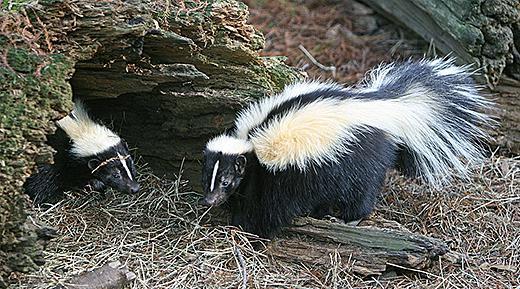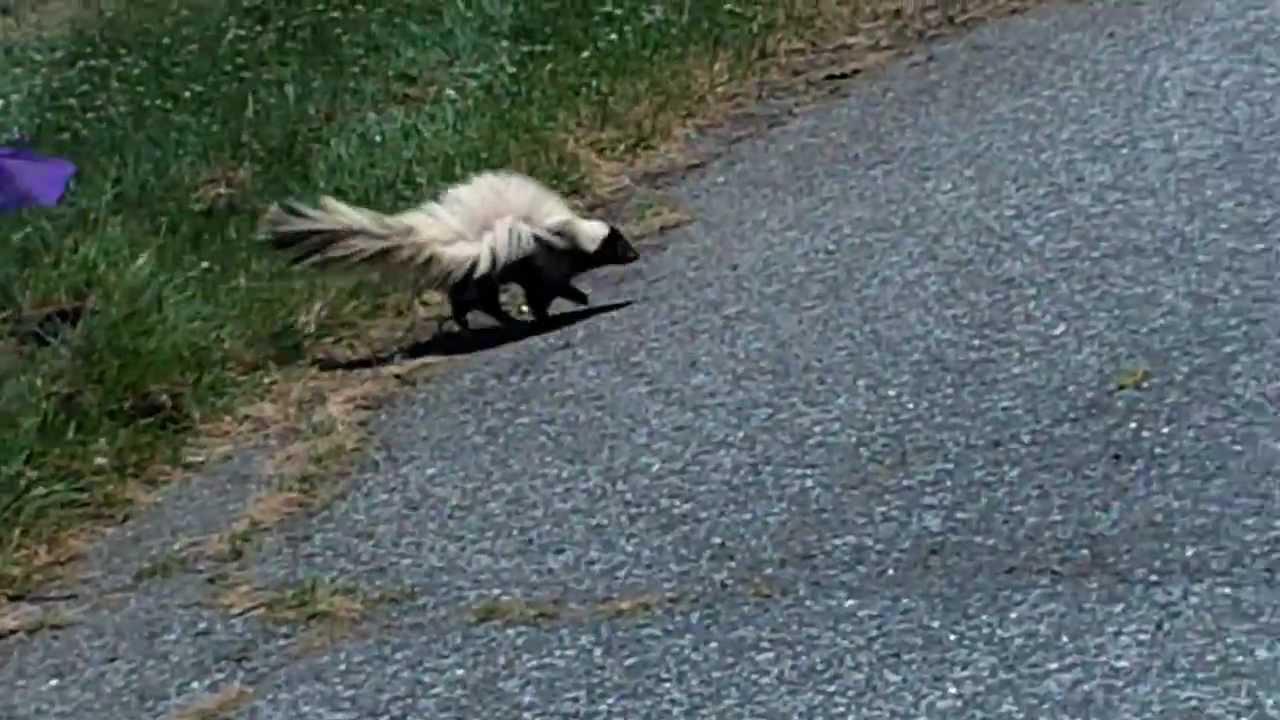The first image is the image on the left, the second image is the image on the right. Given the left and right images, does the statement "There is one skunk in one image, and more than one skunk in the other image." hold true? Answer yes or no. Yes. The first image is the image on the left, the second image is the image on the right. For the images displayed, is the sentence "There are exactly two skunks." factually correct? Answer yes or no. No. 